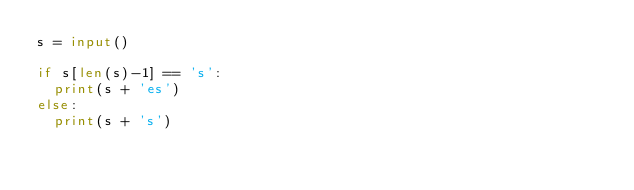Convert code to text. <code><loc_0><loc_0><loc_500><loc_500><_Python_>s = input()

if s[len(s)-1] == 's':
  print(s + 'es')
else:
  print(s + 's')

</code> 